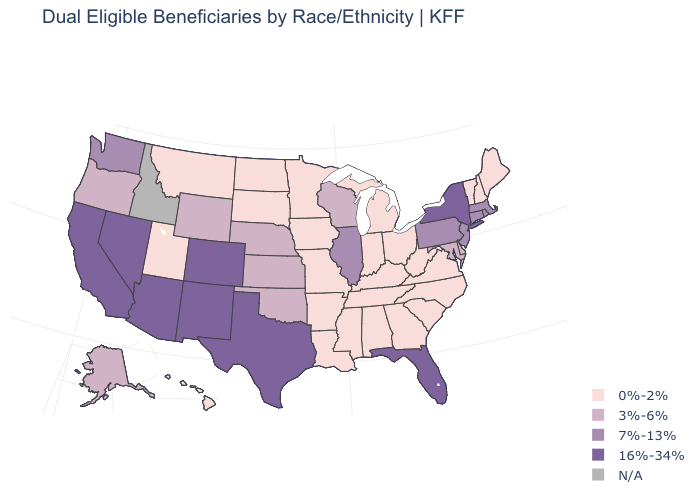Which states hav the highest value in the West?
Give a very brief answer. Arizona, California, Colorado, Nevada, New Mexico. What is the value of Minnesota?
Short answer required. 0%-2%. Name the states that have a value in the range 0%-2%?
Be succinct. Alabama, Arkansas, Georgia, Hawaii, Indiana, Iowa, Kentucky, Louisiana, Maine, Michigan, Minnesota, Mississippi, Missouri, Montana, New Hampshire, North Carolina, North Dakota, Ohio, South Carolina, South Dakota, Tennessee, Utah, Vermont, Virginia, West Virginia. Does Rhode Island have the lowest value in the Northeast?
Answer briefly. No. Does Vermont have the lowest value in the Northeast?
Quick response, please. Yes. What is the value of Wisconsin?
Concise answer only. 3%-6%. Among the states that border Michigan , does Wisconsin have the highest value?
Quick response, please. Yes. What is the value of Kentucky?
Be succinct. 0%-2%. What is the value of Alaska?
Give a very brief answer. 3%-6%. Name the states that have a value in the range 0%-2%?
Write a very short answer. Alabama, Arkansas, Georgia, Hawaii, Indiana, Iowa, Kentucky, Louisiana, Maine, Michigan, Minnesota, Mississippi, Missouri, Montana, New Hampshire, North Carolina, North Dakota, Ohio, South Carolina, South Dakota, Tennessee, Utah, Vermont, Virginia, West Virginia. Does Florida have the highest value in the USA?
Be succinct. Yes. Does New Mexico have the lowest value in the USA?
Concise answer only. No. Name the states that have a value in the range 7%-13%?
Concise answer only. Connecticut, Illinois, Massachusetts, New Jersey, Pennsylvania, Rhode Island, Washington. Name the states that have a value in the range 7%-13%?
Short answer required. Connecticut, Illinois, Massachusetts, New Jersey, Pennsylvania, Rhode Island, Washington. 